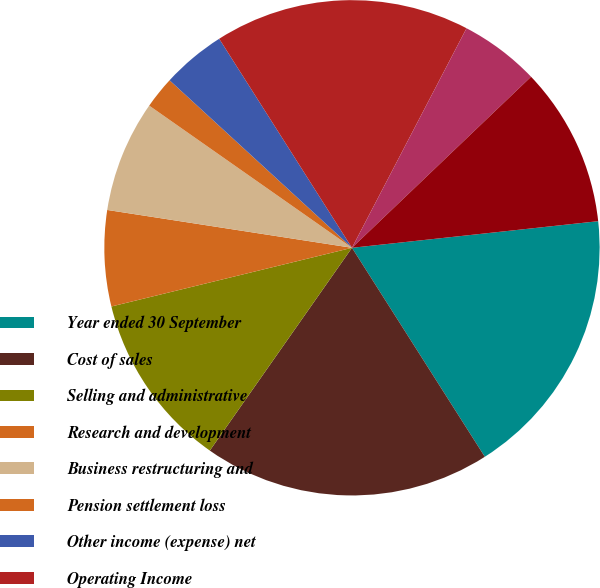<chart> <loc_0><loc_0><loc_500><loc_500><pie_chart><fcel>Year ended 30 September<fcel>Cost of sales<fcel>Selling and administrative<fcel>Research and development<fcel>Business restructuring and<fcel>Pension settlement loss<fcel>Other income (expense) net<fcel>Operating Income<fcel>Interest expense<fcel>Income tax provision<nl><fcel>17.7%<fcel>18.74%<fcel>11.46%<fcel>6.25%<fcel>7.29%<fcel>2.09%<fcel>4.17%<fcel>16.66%<fcel>5.21%<fcel>10.42%<nl></chart> 